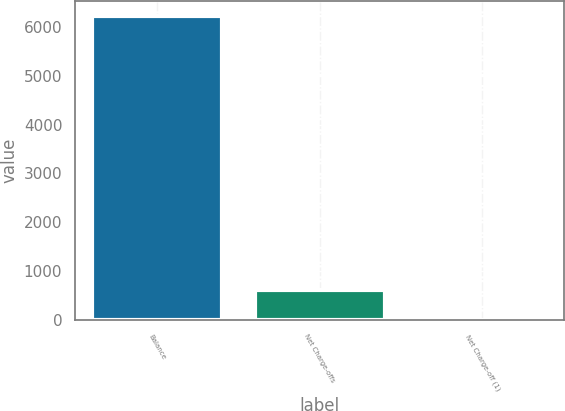Convert chart to OTSL. <chart><loc_0><loc_0><loc_500><loc_500><bar_chart><fcel>Balance<fcel>Net Charge-offs<fcel>Net Charge-off (1)<nl><fcel>6213<fcel>622.58<fcel>1.42<nl></chart> 